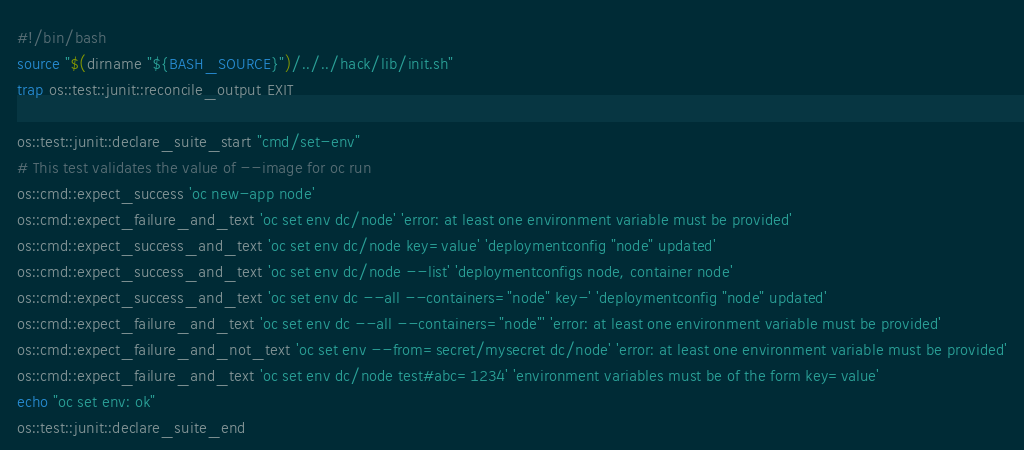<code> <loc_0><loc_0><loc_500><loc_500><_Bash_>#!/bin/bash
source "$(dirname "${BASH_SOURCE}")/../../hack/lib/init.sh"
trap os::test::junit::reconcile_output EXIT

os::test::junit::declare_suite_start "cmd/set-env"
# This test validates the value of --image for oc run
os::cmd::expect_success 'oc new-app node'
os::cmd::expect_failure_and_text 'oc set env dc/node' 'error: at least one environment variable must be provided'
os::cmd::expect_success_and_text 'oc set env dc/node key=value' 'deploymentconfig "node" updated'
os::cmd::expect_success_and_text 'oc set env dc/node --list' 'deploymentconfigs node, container node'
os::cmd::expect_success_and_text 'oc set env dc --all --containers="node" key-' 'deploymentconfig "node" updated'
os::cmd::expect_failure_and_text 'oc set env dc --all --containers="node"' 'error: at least one environment variable must be provided'
os::cmd::expect_failure_and_not_text 'oc set env --from=secret/mysecret dc/node' 'error: at least one environment variable must be provided'
os::cmd::expect_failure_and_text 'oc set env dc/node test#abc=1234' 'environment variables must be of the form key=value'
echo "oc set env: ok"
os::test::junit::declare_suite_end
</code> 